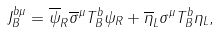<formula> <loc_0><loc_0><loc_500><loc_500>J _ { B } ^ { b \mu } = \overline { \psi } _ { R } \overline { \sigma } ^ { \mu } T _ { B } ^ { b } \psi _ { R } + \overline { \eta } _ { L } \sigma ^ { \mu } T _ { B } ^ { b } \eta _ { L } ,</formula> 